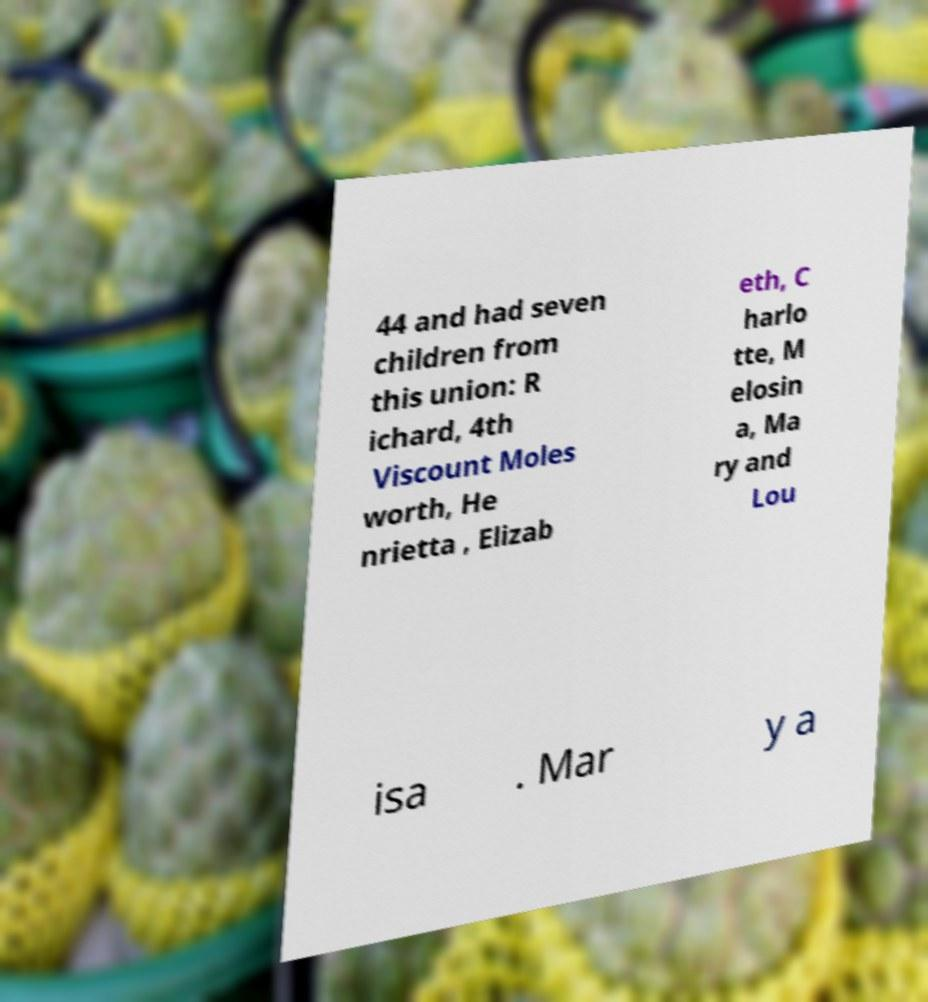There's text embedded in this image that I need extracted. Can you transcribe it verbatim? 44 and had seven children from this union: R ichard, 4th Viscount Moles worth, He nrietta , Elizab eth, C harlo tte, M elosin a, Ma ry and Lou isa . Mar y a 